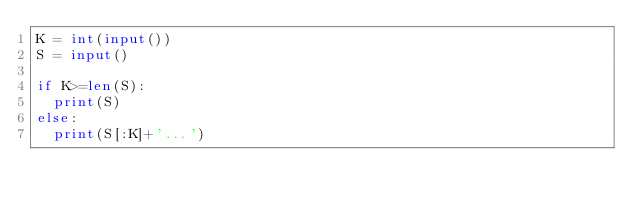<code> <loc_0><loc_0><loc_500><loc_500><_Python_>K = int(input())
S = input()

if K>=len(S):
  print(S)
else:
  print(S[:K]+'...')
 </code> 